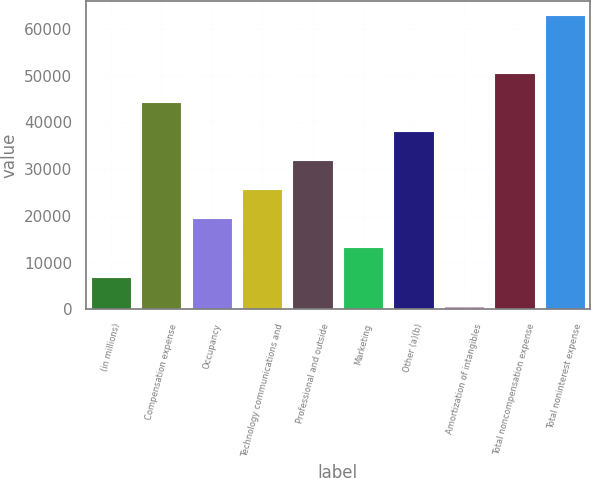<chart> <loc_0><loc_0><loc_500><loc_500><bar_chart><fcel>(in millions)<fcel>Compensation expense<fcel>Occupancy<fcel>Technology communications and<fcel>Professional and outside<fcel>Marketing<fcel>Other (a)(b)<fcel>Amortization of intangibles<fcel>Total noncompensation expense<fcel>Total noninterest expense<nl><fcel>7054.3<fcel>44292.1<fcel>19466.9<fcel>25673.2<fcel>31879.5<fcel>13260.6<fcel>38085.8<fcel>848<fcel>50498.4<fcel>62911<nl></chart> 